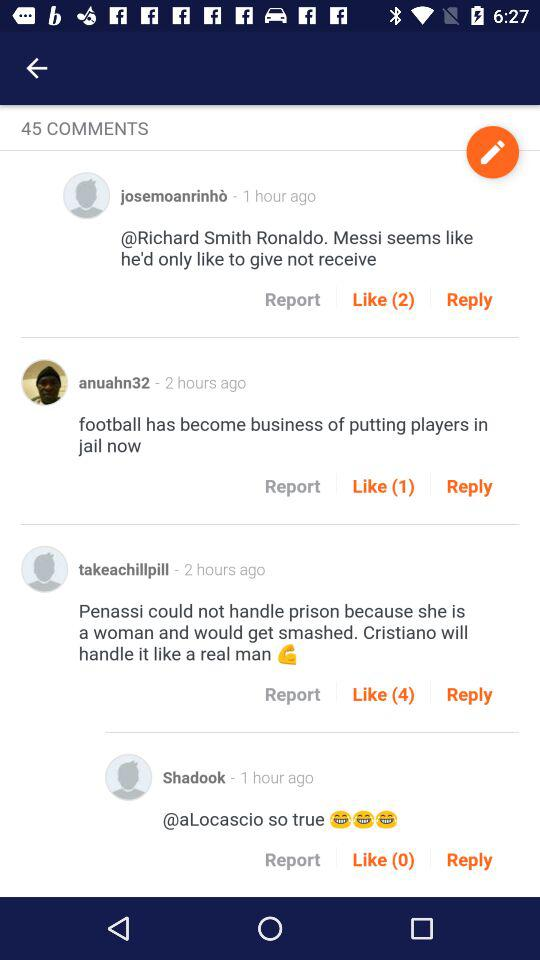When did "josemoanrinhò" make his comment? "josemoanrinhò" made his comment 1 hour ago. 